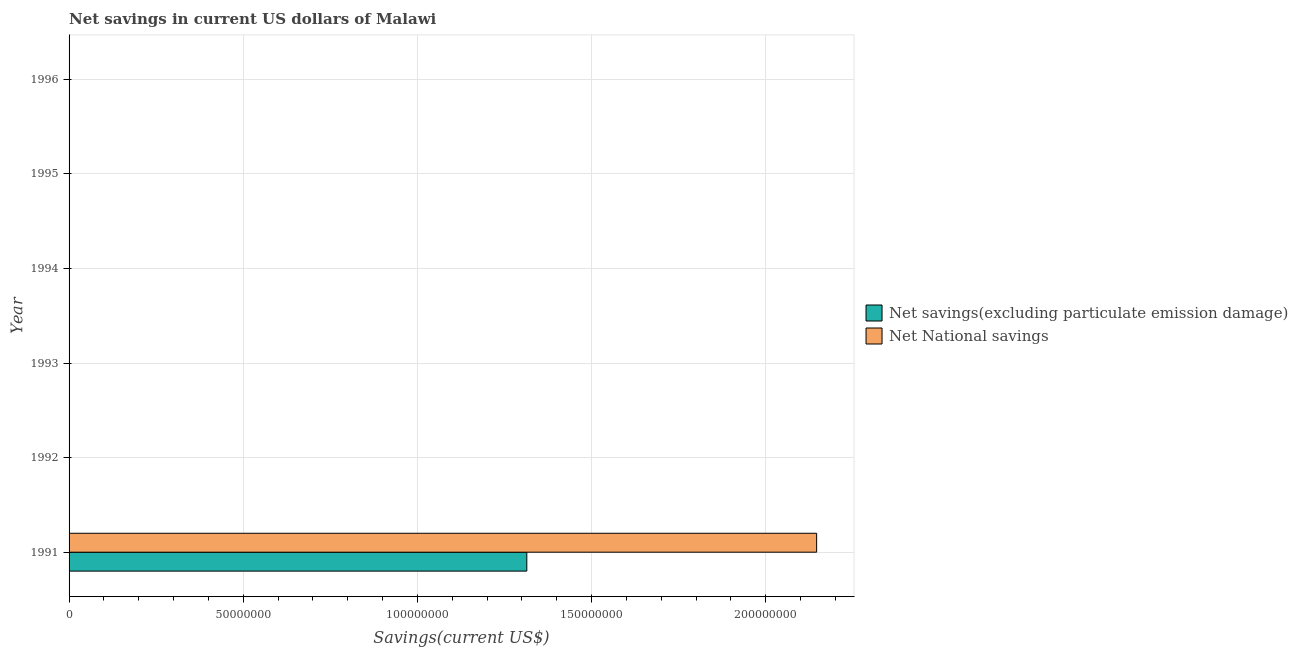Are the number of bars per tick equal to the number of legend labels?
Give a very brief answer. No. How many bars are there on the 6th tick from the bottom?
Keep it short and to the point. 0. What is the label of the 4th group of bars from the top?
Your answer should be very brief. 1993. Across all years, what is the maximum net national savings?
Ensure brevity in your answer.  2.15e+08. What is the total net national savings in the graph?
Provide a short and direct response. 2.15e+08. What is the difference between the net savings(excluding particulate emission damage) in 1996 and the net national savings in 1992?
Give a very brief answer. 0. What is the average net savings(excluding particulate emission damage) per year?
Offer a very short reply. 2.19e+07. In the year 1991, what is the difference between the net savings(excluding particulate emission damage) and net national savings?
Your answer should be very brief. -8.32e+07. What is the difference between the highest and the lowest net national savings?
Offer a terse response. 2.15e+08. Are all the bars in the graph horizontal?
Offer a very short reply. Yes. How many years are there in the graph?
Offer a very short reply. 6. Does the graph contain any zero values?
Provide a short and direct response. Yes. Where does the legend appear in the graph?
Keep it short and to the point. Center right. How many legend labels are there?
Give a very brief answer. 2. What is the title of the graph?
Offer a terse response. Net savings in current US dollars of Malawi. Does "Ages 15-24" appear as one of the legend labels in the graph?
Your answer should be very brief. No. What is the label or title of the X-axis?
Offer a terse response. Savings(current US$). What is the Savings(current US$) of Net savings(excluding particulate emission damage) in 1991?
Make the answer very short. 1.31e+08. What is the Savings(current US$) of Net National savings in 1991?
Provide a succinct answer. 2.15e+08. What is the Savings(current US$) of Net National savings in 1992?
Make the answer very short. 0. What is the Savings(current US$) in Net savings(excluding particulate emission damage) in 1993?
Give a very brief answer. 0. What is the Savings(current US$) in Net savings(excluding particulate emission damage) in 1994?
Provide a short and direct response. 0. What is the Savings(current US$) of Net National savings in 1994?
Offer a terse response. 0. What is the Savings(current US$) of Net savings(excluding particulate emission damage) in 1996?
Your response must be concise. 0. Across all years, what is the maximum Savings(current US$) in Net savings(excluding particulate emission damage)?
Offer a terse response. 1.31e+08. Across all years, what is the maximum Savings(current US$) in Net National savings?
Provide a short and direct response. 2.15e+08. Across all years, what is the minimum Savings(current US$) in Net savings(excluding particulate emission damage)?
Make the answer very short. 0. What is the total Savings(current US$) in Net savings(excluding particulate emission damage) in the graph?
Offer a terse response. 1.31e+08. What is the total Savings(current US$) of Net National savings in the graph?
Keep it short and to the point. 2.15e+08. What is the average Savings(current US$) in Net savings(excluding particulate emission damage) per year?
Make the answer very short. 2.19e+07. What is the average Savings(current US$) of Net National savings per year?
Keep it short and to the point. 3.58e+07. In the year 1991, what is the difference between the Savings(current US$) of Net savings(excluding particulate emission damage) and Savings(current US$) of Net National savings?
Provide a succinct answer. -8.32e+07. What is the difference between the highest and the lowest Savings(current US$) in Net savings(excluding particulate emission damage)?
Your answer should be very brief. 1.31e+08. What is the difference between the highest and the lowest Savings(current US$) in Net National savings?
Provide a short and direct response. 2.15e+08. 